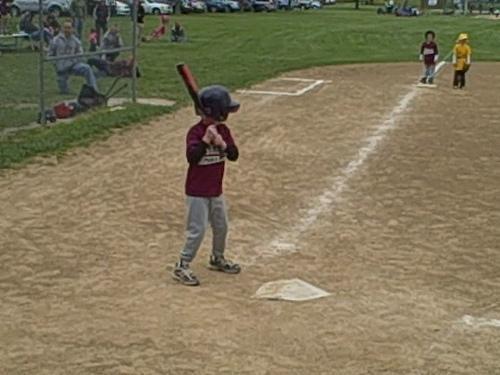How many kids are in the pic?
Give a very brief answer. 3. 